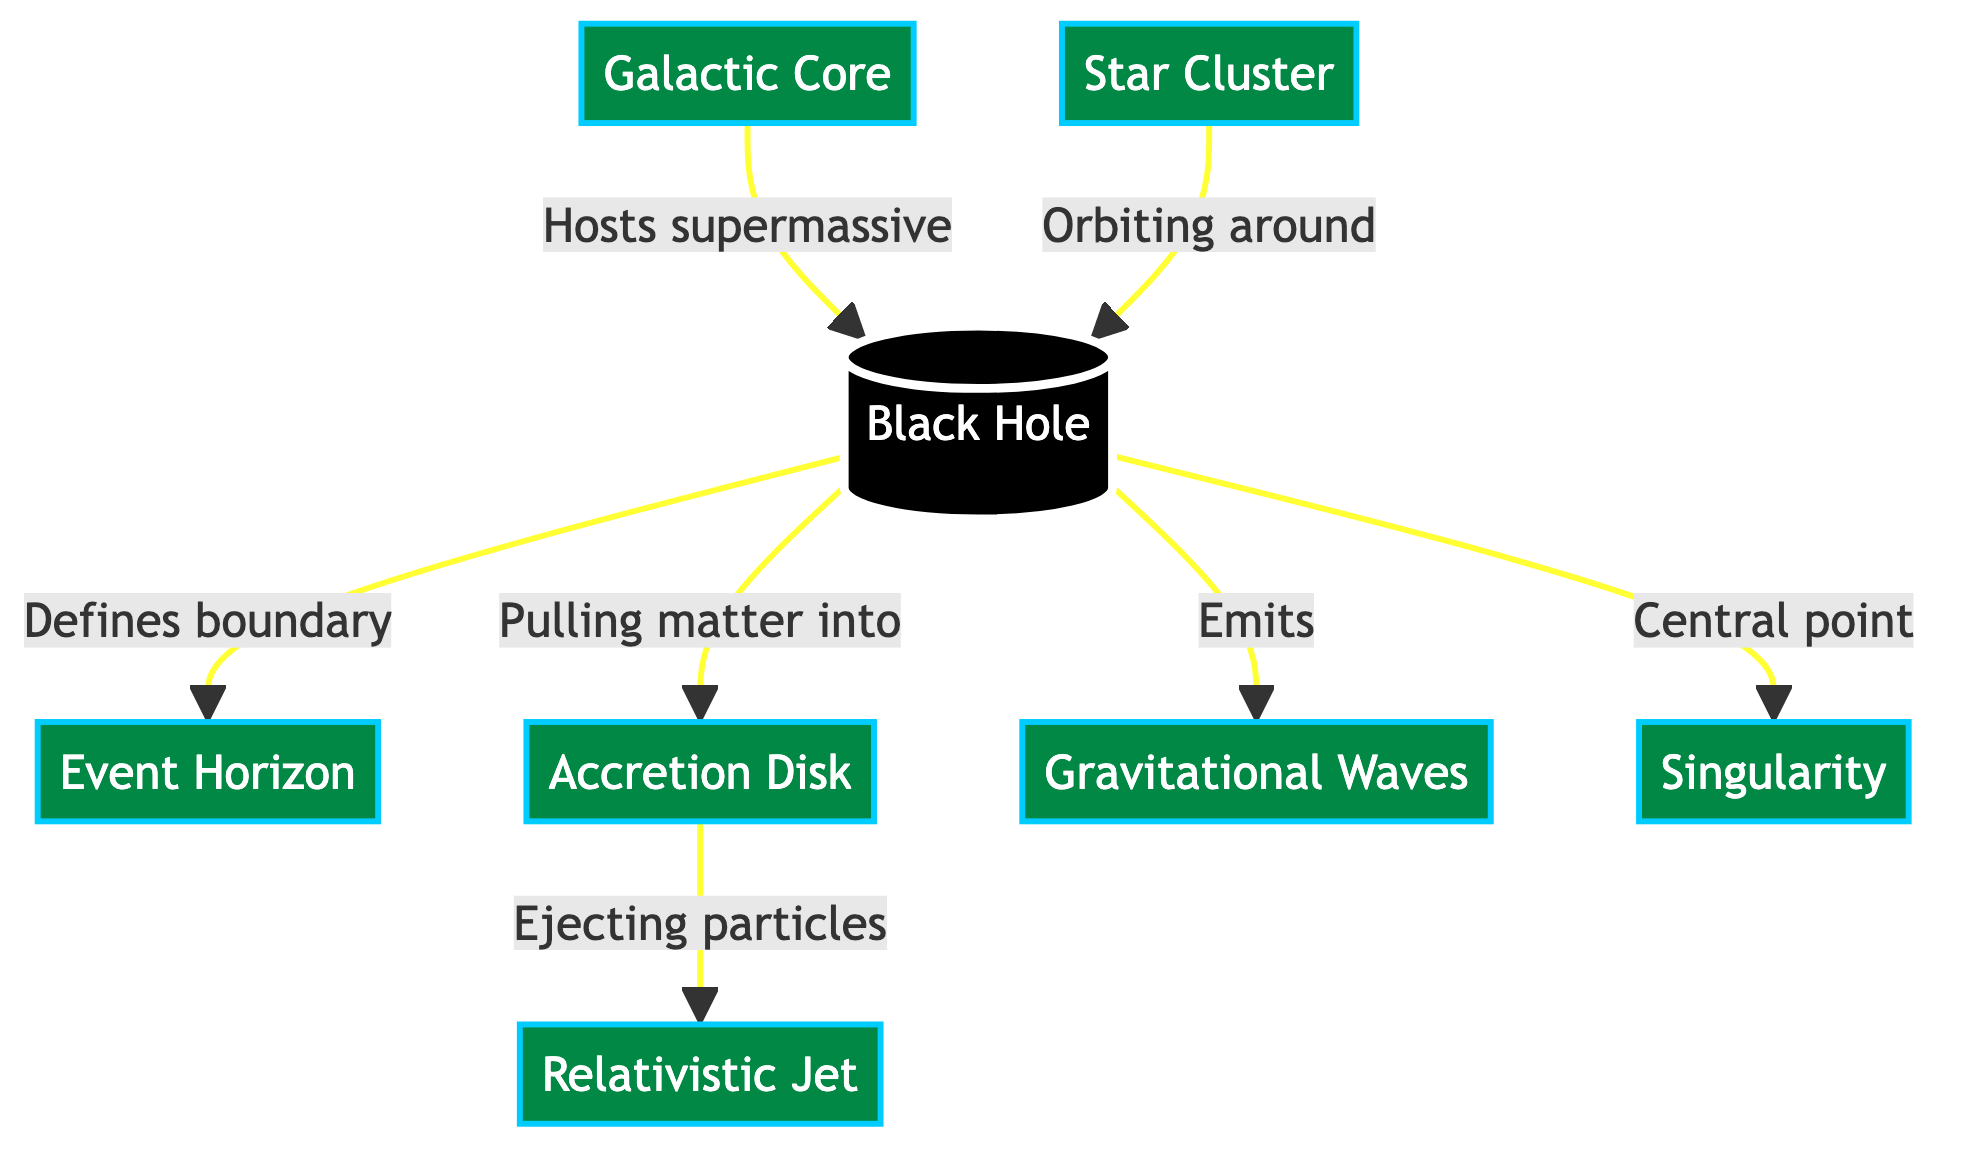What is the central point of the Black Hole? The diagram indicates that the central point of the Black Hole is the Singularity, which is directly connected from the Black Hole node.
Answer: Singularity What does the Accretion Disk eject? According to the diagram, the Accretion Disk is described as "Ejecting particles," indicating that this is the primary output from the Accretion Disk node.
Answer: Particles How many primary components are shown in the diagram? The diagram displays eight distinct components: Black Hole, Event Horizon, Accretion Disk, Jet, Gravitational Waves, Galactic Core, Star Cluster, and Singularity. By counting these nodes, we conclude that there are eight.
Answer: Eight What do Gravitational Waves come from? The diagram illustrates that Gravitational Waves are emitted by the Black Hole, showing a direct connection from Black Hole to Gravitational Waves.
Answer: Black Hole Which component is connected to the Galactic Core? The diagram specifies that the Galactic Core "Hosts supermassive" Black Hole, linking these two components directly. Thus, the Black Hole is the connected component.
Answer: Black Hole What role does the Star Cluster play in the diagram? The diagram indicates that the Star Cluster is "Orbiting around" the Black Hole, suggesting its positional relationship to the Black Hole. Therefore, it plays a role as an orbiting entity.
Answer: Orbiting around Black Hole What is the immediate effect of the Accretion Disk? The Accretion Disk is shown to be "Pulling matter into" the Black Hole, indicating its gravity and influence with its immediate effect being the attraction of matter.
Answer: Pulling matter into Black Hole What is the relationship between the Black Hole and the Event Horizon? The diagram states that the Black Hole "Defines boundary" with the Event Horizon, indicating a direct and defining relationship that outlines the limit of the Black Hole's influence.
Answer: Defines boundary 